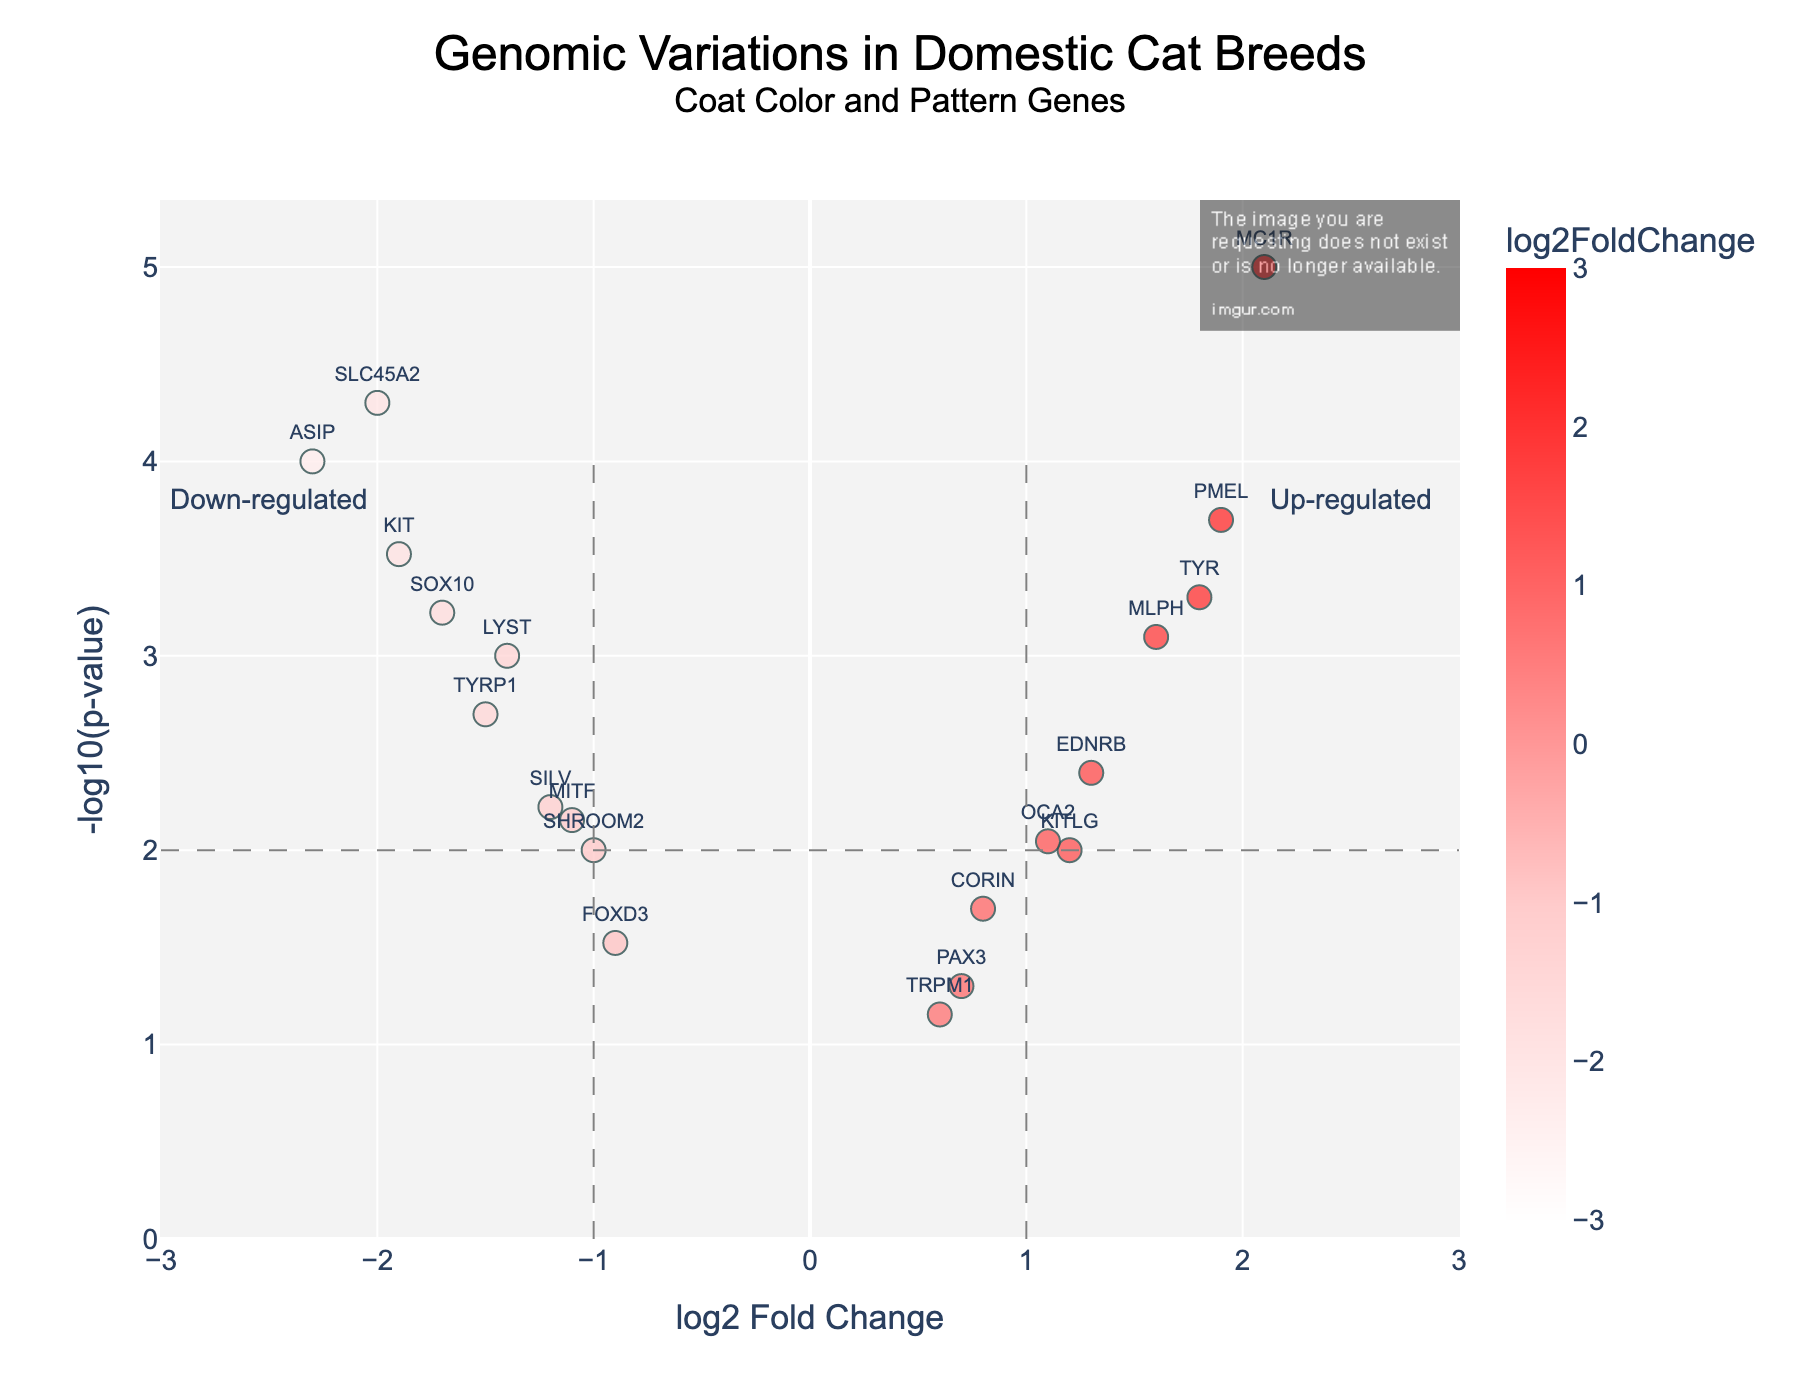What's represented on the y-axis? The y-axis is labeled "-log10(pValue)" and represents the negative logarithm (base 10) of the p-value, which measures statistical significance.
Answer: -log10(pValue) Which gene has the highest log2FoldChange? To find the gene with the highest log2FoldChange, look for the point farthest to the right on the x-axis. This point corresponds to the MC1R gene with a log2FoldChange of 2.1.
Answer: MC1R Which gene is the most statistically significant? The most statistically significant gene will have the highest -log10(pValue), located at the top of the plot. This is the MC1R gene.
Answer: MC1R How many genes have a log2FoldChange greater than 1.0? Count all the points to the right of the log2FoldChange=1 line. These points correspond to the MC1R, PMEL, and TYR, EDNRB, which makes it 4 genes.
Answer: 4 What's the fold change for the ASIP gene? The fold change for the ASIP gene is provided by its log2FoldChange value, which is -2.3.
Answer: -2.3 Which region indicates genes that are up-regulated? Up-regulated genes have a log2FoldChange greater than 1.0, indicated on the right side of the plot beyond the x=1 line.
Answer: Right side beyond x=1 Which gene has the lowest log2FoldChange? The gene with the lowest log2FoldChange is the one farthest to the left on the x-axis, which is ASIP with a log2FoldChange of -2.3.
Answer: ASIP What is the log2FoldChange for the KIT gene, and how does it compare to the MLPH gene? The KIT gene has a log2FoldChange of -1.9, while the MLPH gene has a log2FoldChange of 1.6. The KIT gene has a lower log2FoldChange than the MLPH gene.
Answer: KIT has -1.9, MLPH has 1.6; KIT is lower How many genes have p-values less than 0.001? Genes with p-values less than 0.001 will have a -log10(pValue) greater than 3. Count the points above y=3. These genes include ASIP, MC1R, PMEL, and SLC45A2, giving a total of 4 genes.
Answer: 4 